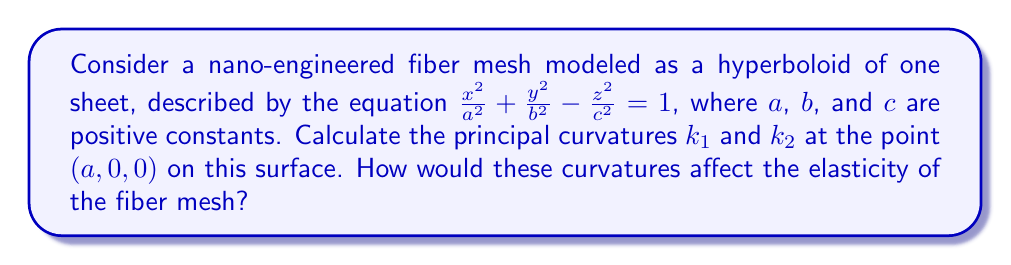Teach me how to tackle this problem. To find the principal curvatures, we'll follow these steps:

1) First, we need to parametrize the surface. Let's use:
   $$x = a\cosh u \cos v$$
   $$y = b\cosh u \sin v$$
   $$z = c\sinh u$$

2) At the point $(a, 0, 0)$, we have $u = 0$ and $v = 0$.

3) Calculate the first fundamental form coefficients:
   $$E = a^2\sinh^2 u \cos^2 v + b^2\sinh^2 u \sin^2 v + c^2\cosh^2 u$$
   $$F = (b^2-a^2)\cosh u \sinh u \sin v \cos v$$
   $$G = a^2\cosh^2 u \sin^2 v + b^2\cosh^2 u \cos^2 v$$

   At $(a, 0, 0)$: $E = c^2$, $F = 0$, $G = a^2$

4) Calculate the second fundamental form coefficients:
   $$L = \frac{ac}{\sqrt{a^2\sinh^2 u \cos^2 v + b^2\sinh^2 u \sin^2 v + c^2\cosh^2 u}}$$
   $$M = 0$$
   $$N = -\frac{a\cosh u}{\sqrt{a^2\sinh^2 u \cos^2 v + b^2\sinh^2 u \sin^2 v + c^2\cosh^2 u}}$$

   At $(a, 0, 0)$: $L = \frac{ac}{c} = a$, $M = 0$, $N = -\frac{a}{c}$

5) The principal curvatures are the eigenvalues of the shape operator, given by:
   $$\begin{pmatrix}
   \frac{L}{E} & \frac{M}{E} \\
   \frac{M}{G} & \frac{N}{G}
   \end{pmatrix} = \begin{pmatrix}
   \frac{a}{c^2} & 0 \\
   0 & -\frac{1}{ac}
   \end{pmatrix}$$

6) Therefore, the principal curvatures are:
   $$k_1 = \frac{a}{c^2}$$
   $$k_2 = -\frac{1}{ac}$$

These curvatures affect the elasticity of the fiber mesh as follows:
- $k_1 > 0$ indicates that the surface is convex in one principal direction, providing resistance to compression.
- $k_2 < 0$ indicates that the surface is concave in the other principal direction, allowing for expansion.
- The combination of positive and negative curvatures creates a saddle-like structure, which can enhance the overall elasticity of the mesh by allowing it to stretch and compress in different directions.
Answer: $k_1 = \frac{a}{c^2}$, $k_2 = -\frac{1}{ac}$ 